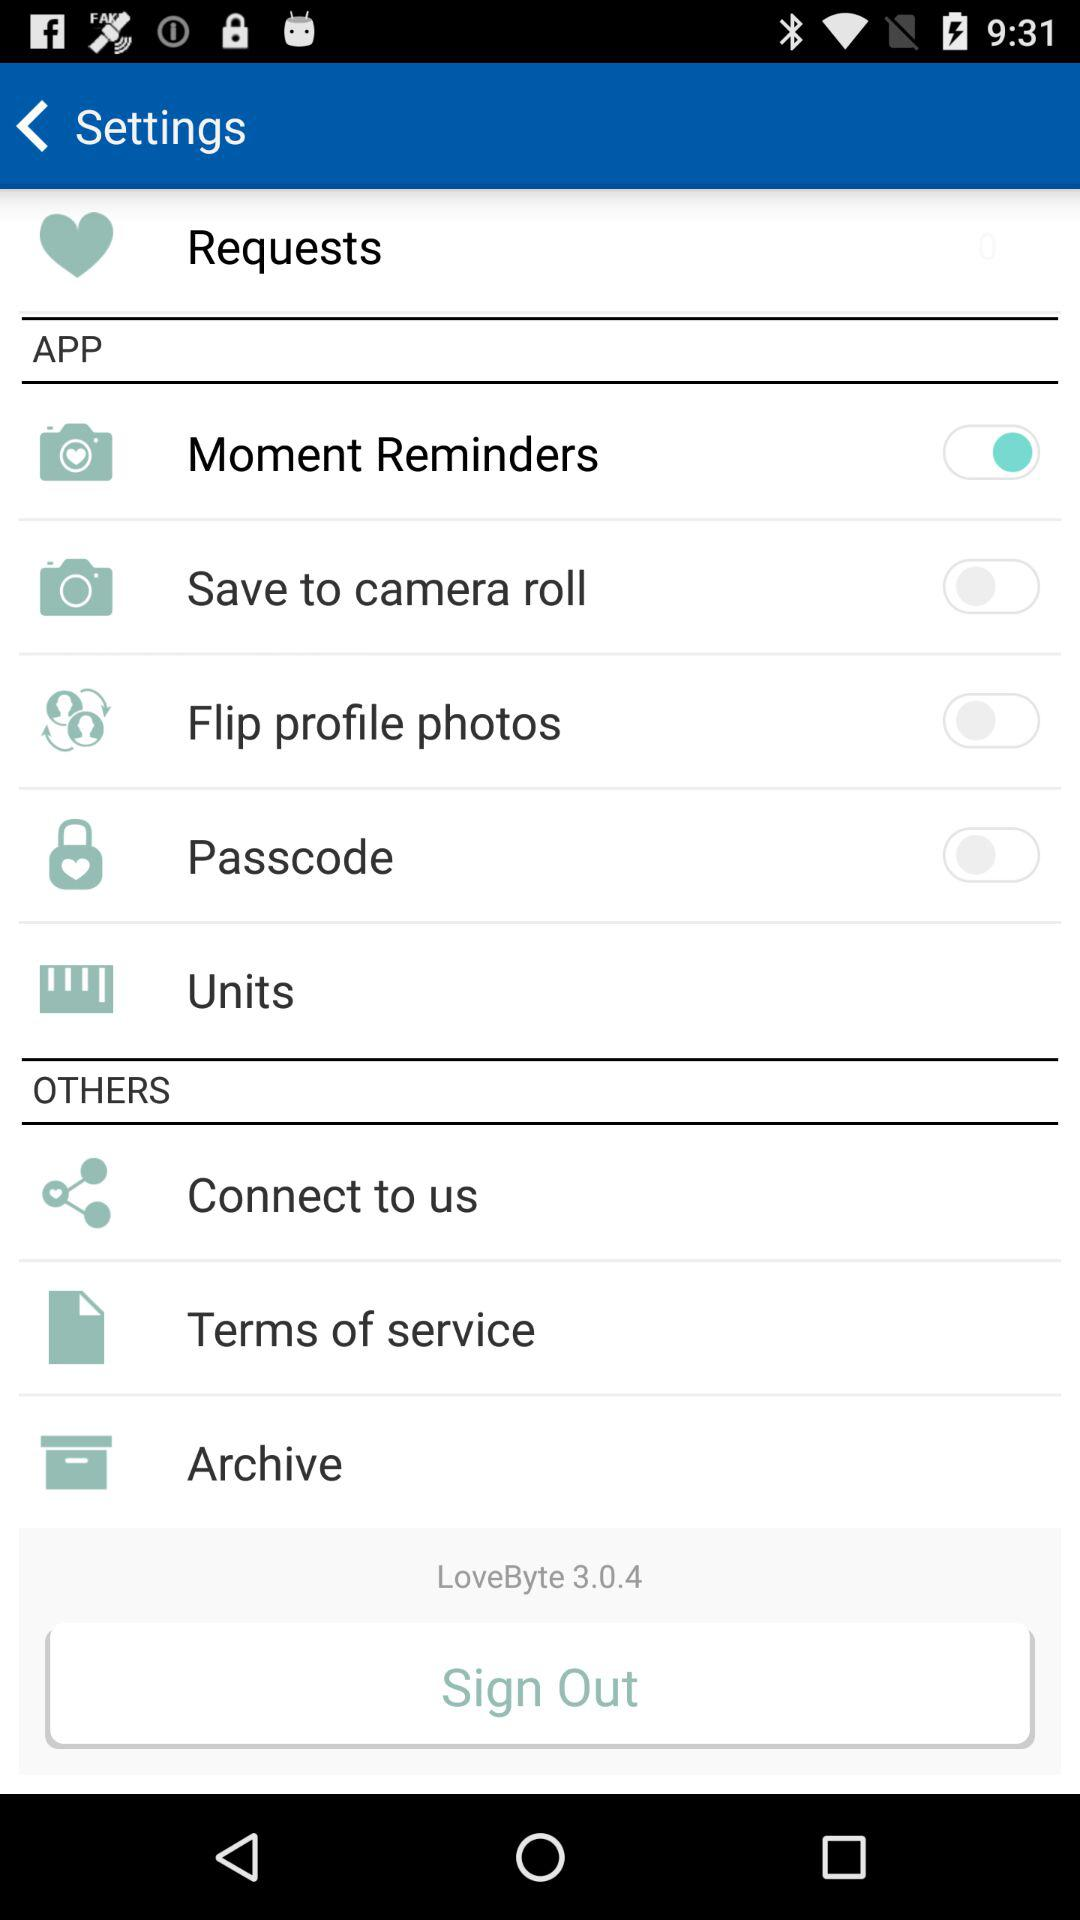How many of the settings have switches?
Answer the question using a single word or phrase. 4 